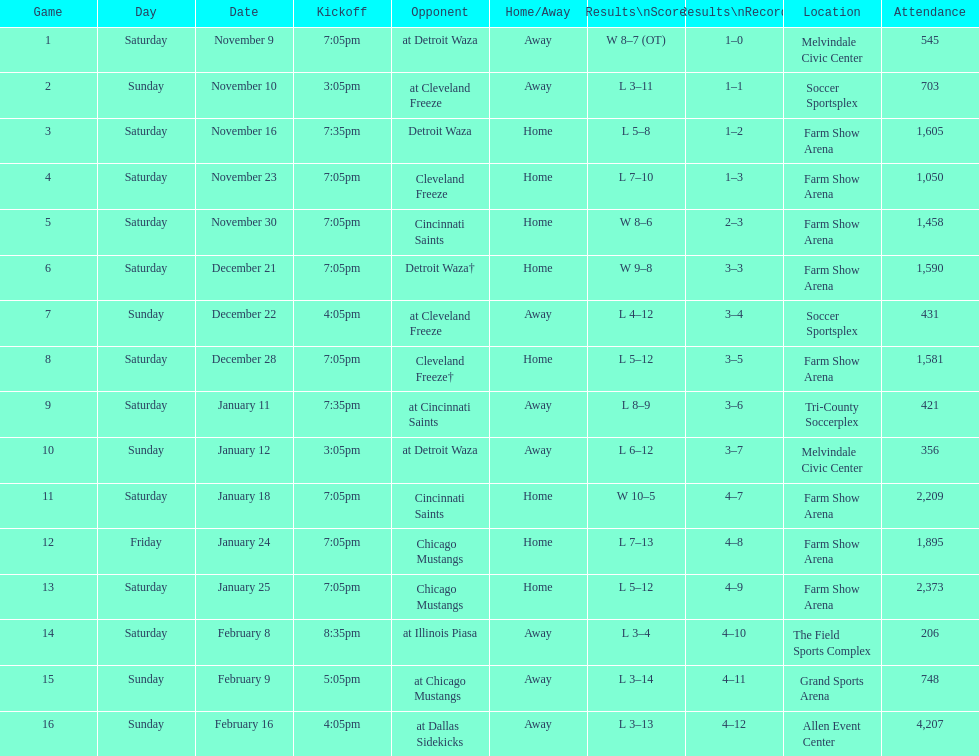How long was the teams longest losing streak? 5 games. 